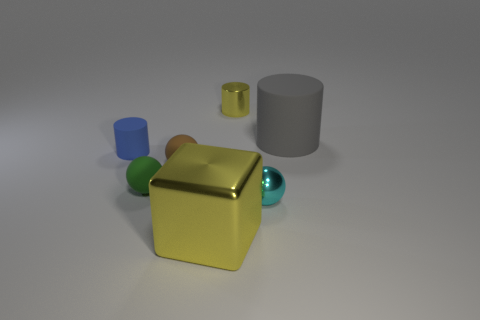Subtract all tiny rubber spheres. How many spheres are left? 1 Add 3 big red matte cubes. How many objects exist? 10 Subtract all balls. How many objects are left? 4 Subtract 3 balls. How many balls are left? 0 Subtract all purple cylinders. Subtract all brown cubes. How many cylinders are left? 3 Subtract all cyan spheres. Subtract all rubber cylinders. How many objects are left? 4 Add 4 gray matte cylinders. How many gray matte cylinders are left? 5 Add 1 green rubber spheres. How many green rubber spheres exist? 2 Subtract all brown spheres. How many spheres are left? 2 Subtract 1 gray cylinders. How many objects are left? 6 